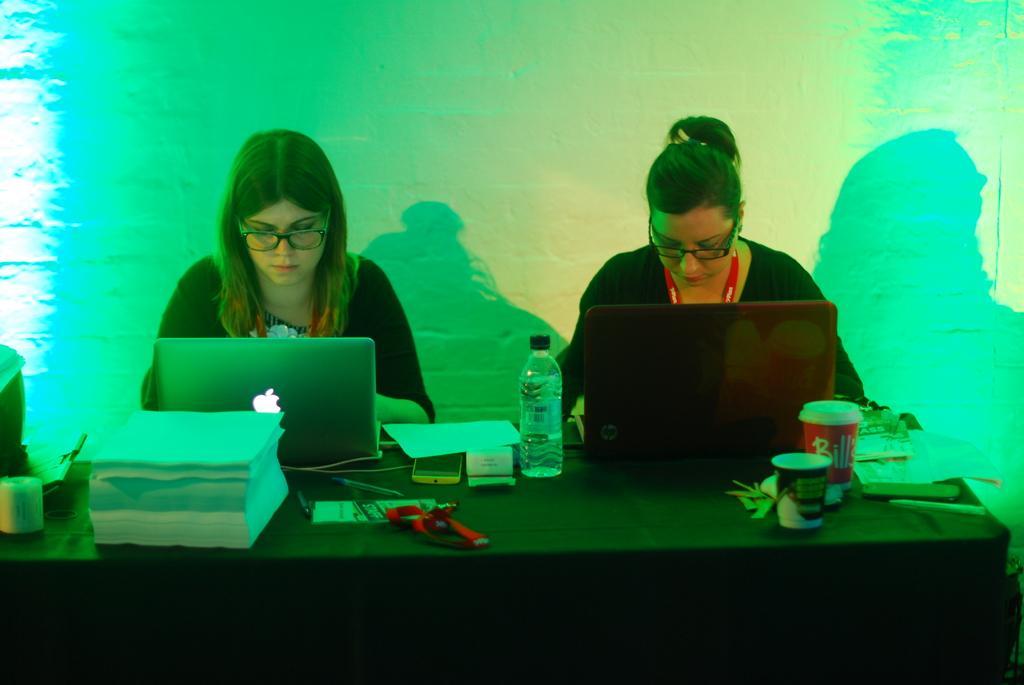Please provide a concise description of this image. In this picture we can see two ladies are sitting and operating the laptops. In-front of them, we can see a table covered with cloth. On the table we can see the papers, glasses, bottle, mobile, id card, printing machine, laptops, books. In the background of the image we can see the wall. 